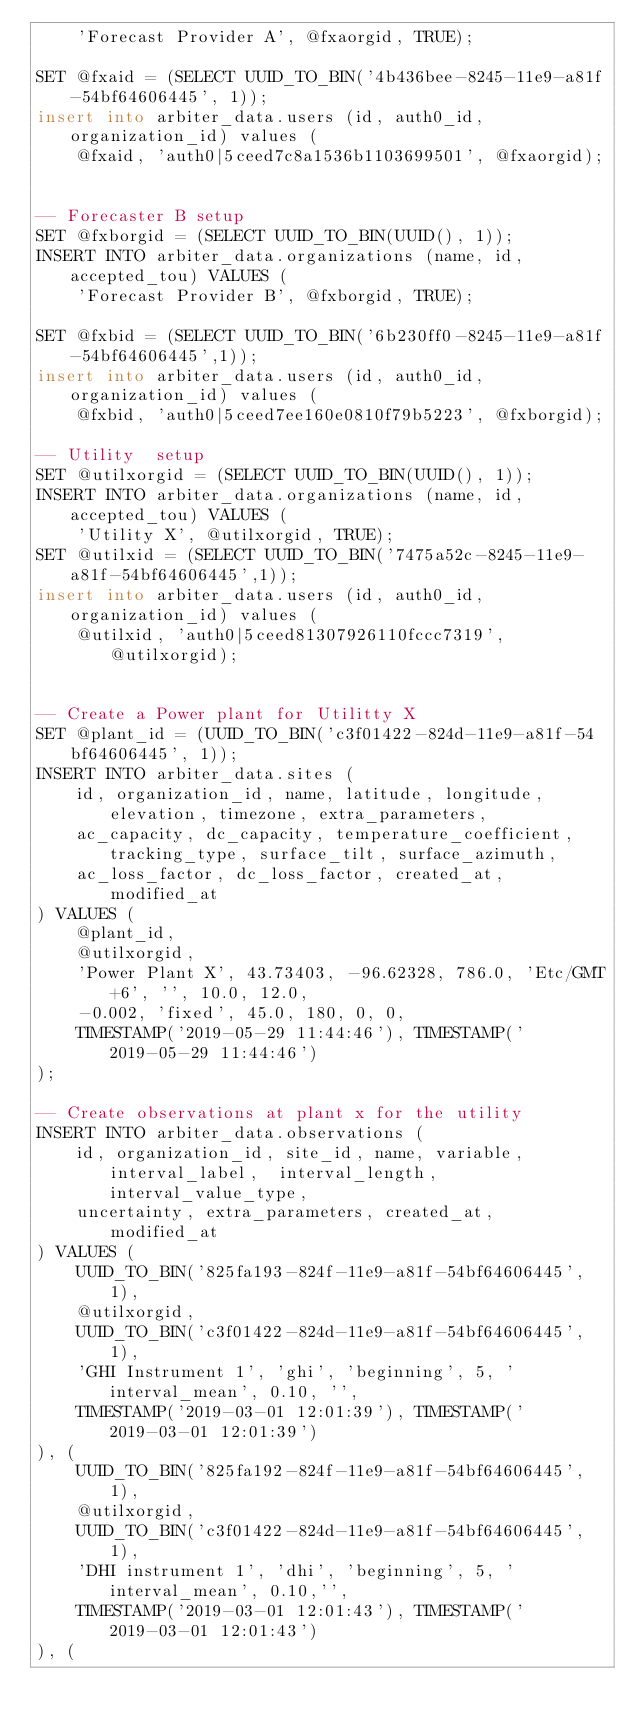Convert code to text. <code><loc_0><loc_0><loc_500><loc_500><_SQL_>    'Forecast Provider A', @fxaorgid, TRUE);

SET @fxaid = (SELECT UUID_TO_BIN('4b436bee-8245-11e9-a81f-54bf64606445', 1));
insert into arbiter_data.users (id, auth0_id, organization_id) values (
    @fxaid, 'auth0|5ceed7c8a1536b1103699501', @fxaorgid);


-- Forecaster B setup
SET @fxborgid = (SELECT UUID_TO_BIN(UUID(), 1));
INSERT INTO arbiter_data.organizations (name, id, accepted_tou) VALUES (
    'Forecast Provider B', @fxborgid, TRUE);

SET @fxbid = (SELECT UUID_TO_BIN('6b230ff0-8245-11e9-a81f-54bf64606445',1));
insert into arbiter_data.users (id, auth0_id, organization_id) values (
    @fxbid, 'auth0|5ceed7ee160e0810f79b5223', @fxborgid);

-- Utility  setup
SET @utilxorgid = (SELECT UUID_TO_BIN(UUID(), 1));
INSERT INTO arbiter_data.organizations (name, id, accepted_tou) VALUES (
    'Utility X', @utilxorgid, TRUE);
SET @utilxid = (SELECT UUID_TO_BIN('7475a52c-8245-11e9-a81f-54bf64606445',1));
insert into arbiter_data.users (id, auth0_id, organization_id) values (
    @utilxid, 'auth0|5ceed81307926110fccc7319', @utilxorgid);


-- Create a Power plant for Utilitty X 
SET @plant_id = (UUID_TO_BIN('c3f01422-824d-11e9-a81f-54bf64606445', 1));
INSERT INTO arbiter_data.sites (
    id, organization_id, name, latitude, longitude, elevation, timezone, extra_parameters,
    ac_capacity, dc_capacity, temperature_coefficient, tracking_type, surface_tilt, surface_azimuth,
    ac_loss_factor, dc_loss_factor, created_at, modified_at
) VALUES (
    @plant_id, 
    @utilxorgid, 
    'Power Plant X', 43.73403, -96.62328, 786.0, 'Etc/GMT+6', '', 10.0, 12.0, 
    -0.002, 'fixed', 45.0, 180, 0, 0, 
    TIMESTAMP('2019-05-29 11:44:46'), TIMESTAMP('2019-05-29 11:44:46') 
);

-- Create observations at plant x for the utility 
INSERT INTO arbiter_data.observations (
    id, organization_id, site_id, name, variable, interval_label,  interval_length, interval_value_type,
    uncertainty, extra_parameters, created_at, modified_at
) VALUES (
    UUID_TO_BIN('825fa193-824f-11e9-a81f-54bf64606445', 1),
    @utilxorgid,
    UUID_TO_BIN('c3f01422-824d-11e9-a81f-54bf64606445', 1),
    'GHI Instrument 1', 'ghi', 'beginning', 5, 'interval_mean', 0.10, '',
    TIMESTAMP('2019-03-01 12:01:39'), TIMESTAMP('2019-03-01 12:01:39')
), (
    UUID_TO_BIN('825fa192-824f-11e9-a81f-54bf64606445', 1),
    @utilxorgid,
    UUID_TO_BIN('c3f01422-824d-11e9-a81f-54bf64606445', 1),
    'DHI instrument 1', 'dhi', 'beginning', 5, 'interval_mean', 0.10,'',
    TIMESTAMP('2019-03-01 12:01:43'), TIMESTAMP('2019-03-01 12:01:43')
), (</code> 